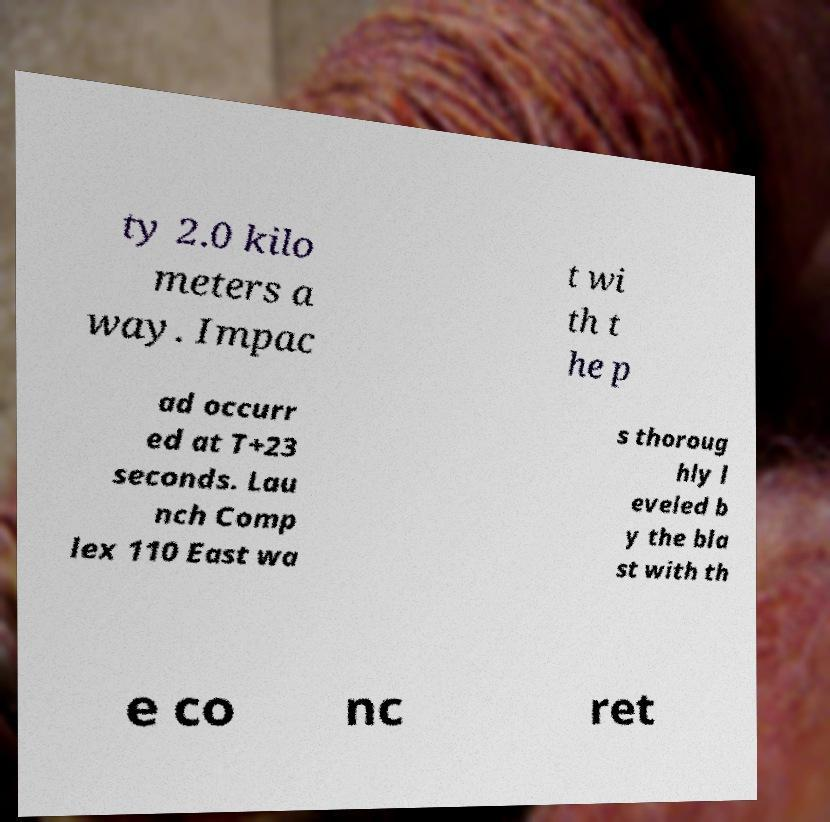I need the written content from this picture converted into text. Can you do that? ty 2.0 kilo meters a way. Impac t wi th t he p ad occurr ed at T+23 seconds. Lau nch Comp lex 110 East wa s thoroug hly l eveled b y the bla st with th e co nc ret 